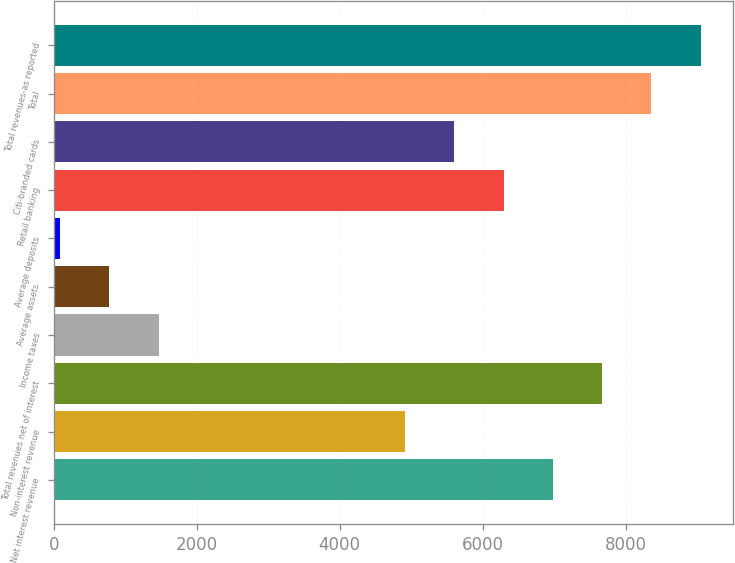<chart> <loc_0><loc_0><loc_500><loc_500><bar_chart><fcel>Net interest revenue<fcel>Non-interest revenue<fcel>Total revenues net of interest<fcel>Income taxes<fcel>Average assets<fcel>Average deposits<fcel>Retail banking<fcel>Citi-branded cards<fcel>Total<fcel>Total revenues-as reported<nl><fcel>6980<fcel>4912.85<fcel>7669.05<fcel>1467.6<fcel>778.55<fcel>89.5<fcel>6290.95<fcel>5601.9<fcel>8358.1<fcel>9047.15<nl></chart> 